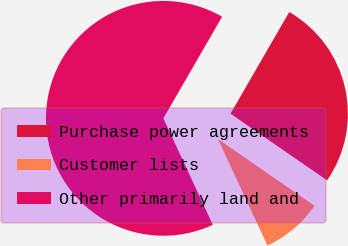Convert chart to OTSL. <chart><loc_0><loc_0><loc_500><loc_500><pie_chart><fcel>Purchase power agreements<fcel>Customer lists<fcel>Other primarily land and<nl><fcel>26.28%<fcel>8.46%<fcel>65.26%<nl></chart> 